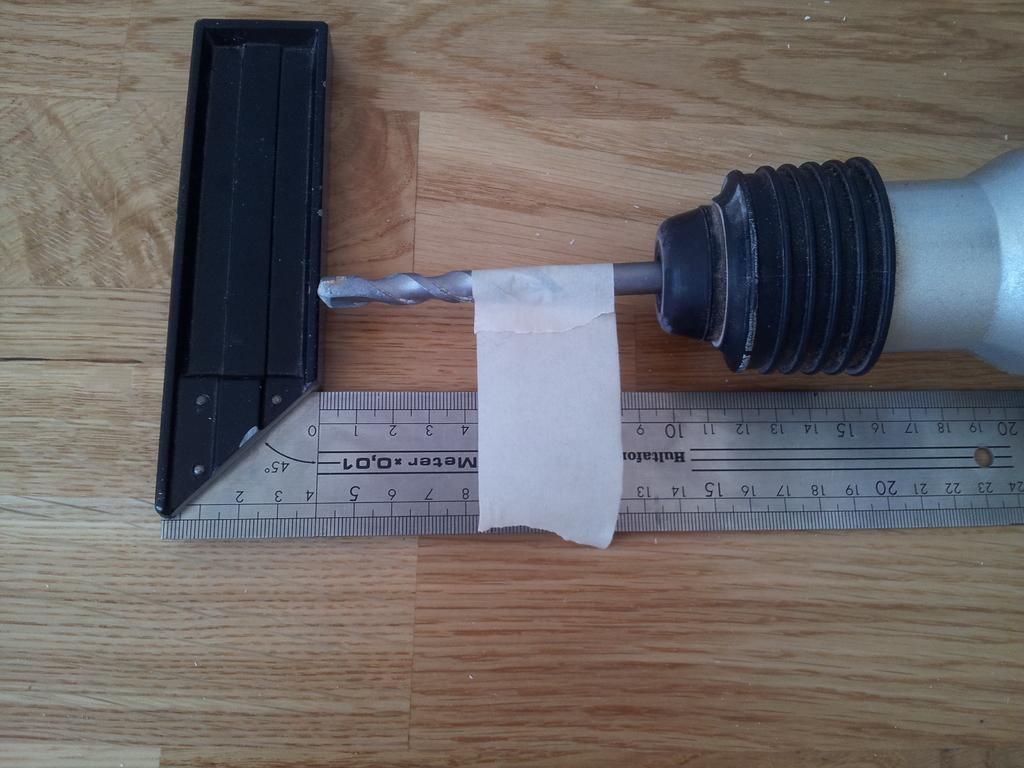<image>
Present a compact description of the photo's key features. a ruler that says the number 45 on a section of it 